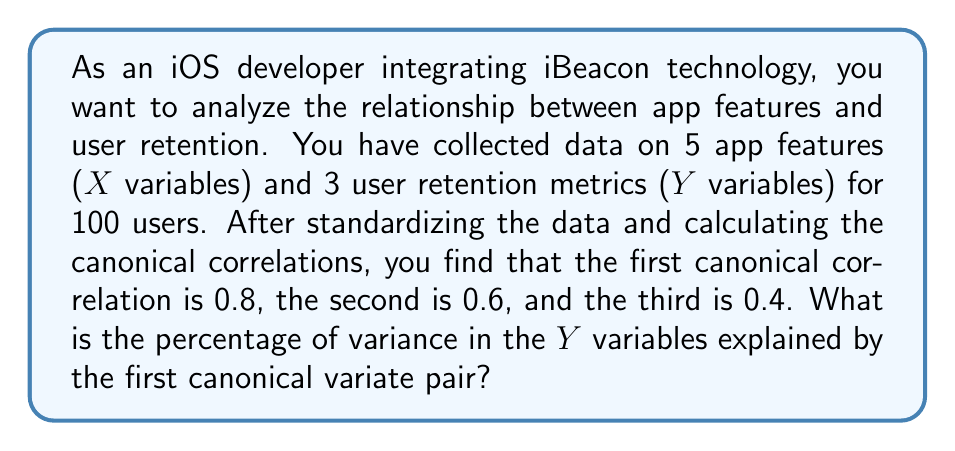Solve this math problem. To solve this problem, we need to understand the concept of canonical correlation analysis and how to calculate the explained variance.

1. Canonical correlation analysis (CCA) finds linear combinations of X and Y variables that have maximum correlation with each other.

2. The squared canonical correlations represent the amount of shared variance between the canonical variates.

3. To calculate the percentage of variance explained by a canonical variate pair, we use the following formula:

   $$\text{Variance Explained} = \frac{\lambda_i^2}{\sum_{j=1}^p \lambda_j^2} \times 100\%$$

   where $\lambda_i$ is the i-th canonical correlation, and p is the number of canonical correlations.

4. In this case, we have:
   $\lambda_1 = 0.8$
   $\lambda_2 = 0.6$
   $\lambda_3 = 0.4$

5. Calculate the sum of squared canonical correlations:
   $$\sum_{j=1}^3 \lambda_j^2 = 0.8^2 + 0.6^2 + 0.4^2 = 0.64 + 0.36 + 0.16 = 1.16$$

6. Calculate the variance explained by the first canonical variate pair:
   $$\text{Variance Explained} = \frac{0.8^2}{1.16} \times 100\% = \frac{0.64}{1.16} \times 100\% \approx 55.17\%$$

Therefore, the first canonical variate pair explains approximately 55.17% of the variance in the Y variables (user retention metrics).
Answer: 55.17% 